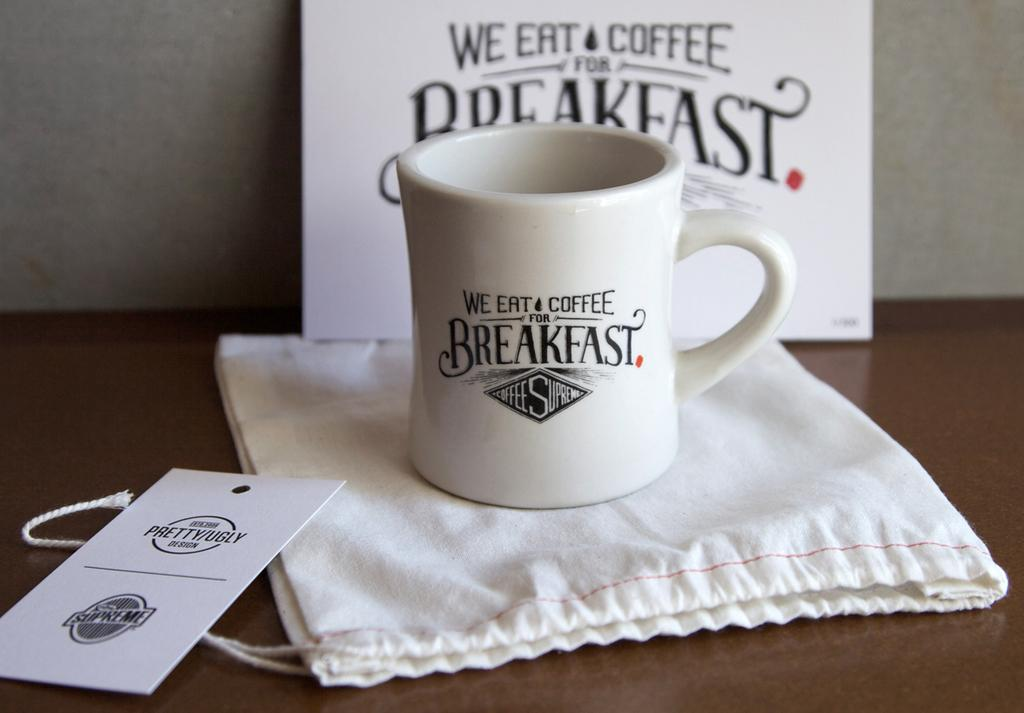<image>
Share a concise interpretation of the image provided. A mug that says We Eat Coffee for Breakfast. 